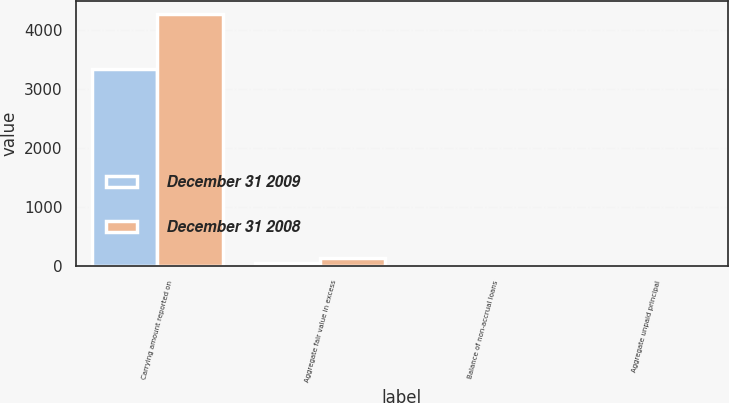Convert chart. <chart><loc_0><loc_0><loc_500><loc_500><stacked_bar_chart><ecel><fcel>Carrying amount reported on<fcel>Aggregate fair value in excess<fcel>Balance of non-accrual loans<fcel>Aggregate unpaid principal<nl><fcel>December 31 2009<fcel>3338<fcel>55<fcel>4<fcel>3<nl><fcel>December 31 2008<fcel>4273<fcel>138<fcel>9<fcel>2<nl></chart> 